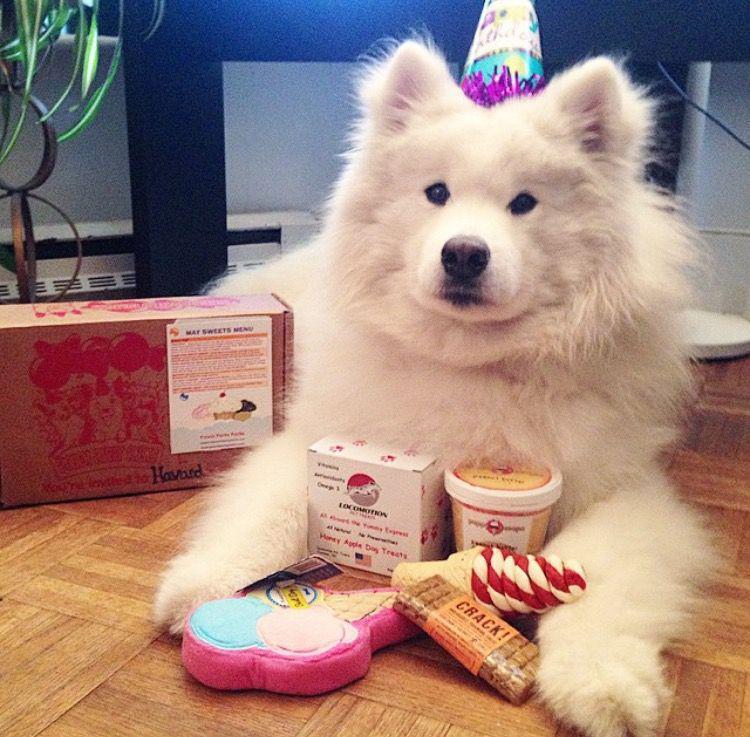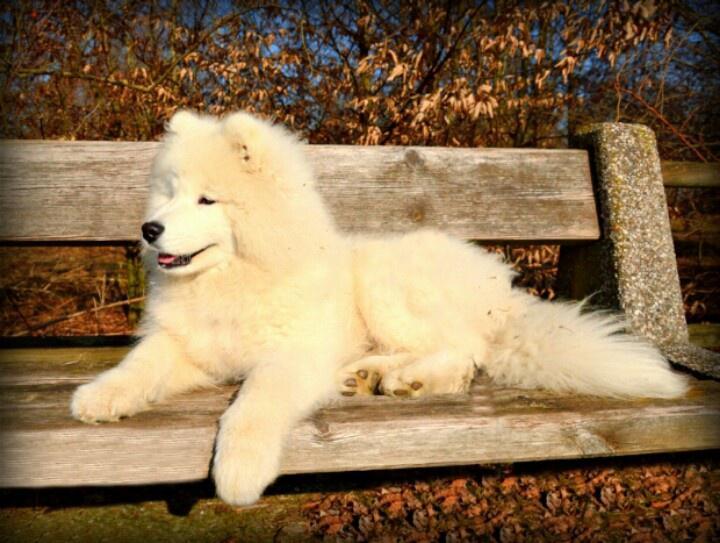The first image is the image on the left, the second image is the image on the right. Given the left and right images, does the statement "there are two dogs in the image pair" hold true? Answer yes or no. Yes. The first image is the image on the left, the second image is the image on the right. Considering the images on both sides, is "There are two dogs." valid? Answer yes or no. Yes. 